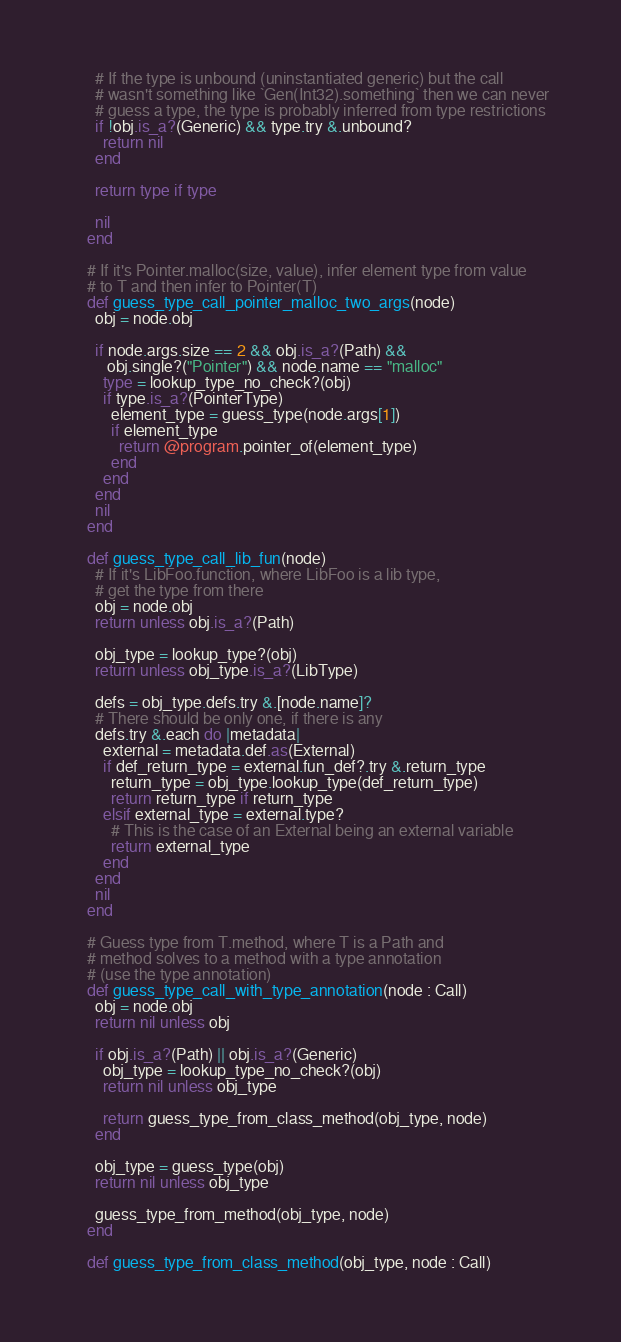Convert code to text. <code><loc_0><loc_0><loc_500><loc_500><_Crystal_>
      # If the type is unbound (uninstantiated generic) but the call
      # wasn't something like `Gen(Int32).something` then we can never
      # guess a type, the type is probably inferred from type restrictions
      if !obj.is_a?(Generic) && type.try &.unbound?
        return nil
      end

      return type if type

      nil
    end

    # If it's Pointer.malloc(size, value), infer element type from value
    # to T and then infer to Pointer(T)
    def guess_type_call_pointer_malloc_two_args(node)
      obj = node.obj

      if node.args.size == 2 && obj.is_a?(Path) &&
         obj.single?("Pointer") && node.name == "malloc"
        type = lookup_type_no_check?(obj)
        if type.is_a?(PointerType)
          element_type = guess_type(node.args[1])
          if element_type
            return @program.pointer_of(element_type)
          end
        end
      end
      nil
    end

    def guess_type_call_lib_fun(node)
      # If it's LibFoo.function, where LibFoo is a lib type,
      # get the type from there
      obj = node.obj
      return unless obj.is_a?(Path)

      obj_type = lookup_type?(obj)
      return unless obj_type.is_a?(LibType)

      defs = obj_type.defs.try &.[node.name]?
      # There should be only one, if there is any
      defs.try &.each do |metadata|
        external = metadata.def.as(External)
        if def_return_type = external.fun_def?.try &.return_type
          return_type = obj_type.lookup_type(def_return_type)
          return return_type if return_type
        elsif external_type = external.type?
          # This is the case of an External being an external variable
          return external_type
        end
      end
      nil
    end

    # Guess type from T.method, where T is a Path and
    # method solves to a method with a type annotation
    # (use the type annotation)
    def guess_type_call_with_type_annotation(node : Call)
      obj = node.obj
      return nil unless obj

      if obj.is_a?(Path) || obj.is_a?(Generic)
        obj_type = lookup_type_no_check?(obj)
        return nil unless obj_type

        return guess_type_from_class_method(obj_type, node)
      end

      obj_type = guess_type(obj)
      return nil unless obj_type

      guess_type_from_method(obj_type, node)
    end

    def guess_type_from_class_method(obj_type, node : Call)</code> 